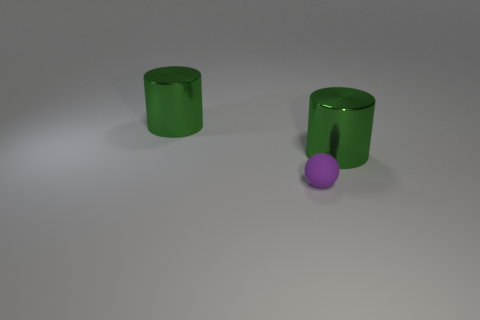Are there fewer purple rubber things than shiny objects?
Offer a very short reply. Yes. The large thing that is to the left of the metallic thing right of the tiny object is made of what material?
Your answer should be compact. Metal. What number of things are cylinders or yellow metal things?
Ensure brevity in your answer.  2. Is the number of big green cylinders behind the tiny purple thing less than the number of small spheres?
Your response must be concise. No. There is a big green thing that is left of the small purple rubber thing; does it have the same shape as the green thing that is to the right of the small purple matte thing?
Ensure brevity in your answer.  Yes. Is the material of the green cylinder to the left of the small purple thing the same as the tiny purple ball?
Make the answer very short. No. Are there any big brown matte cubes?
Your answer should be very brief. No. Is there another small rubber ball that has the same color as the small matte sphere?
Provide a short and direct response. No. Does the large object that is to the right of the tiny ball have the same color as the large cylinder that is left of the tiny purple ball?
Make the answer very short. Yes. Is there another small object that has the same material as the tiny object?
Ensure brevity in your answer.  No. 